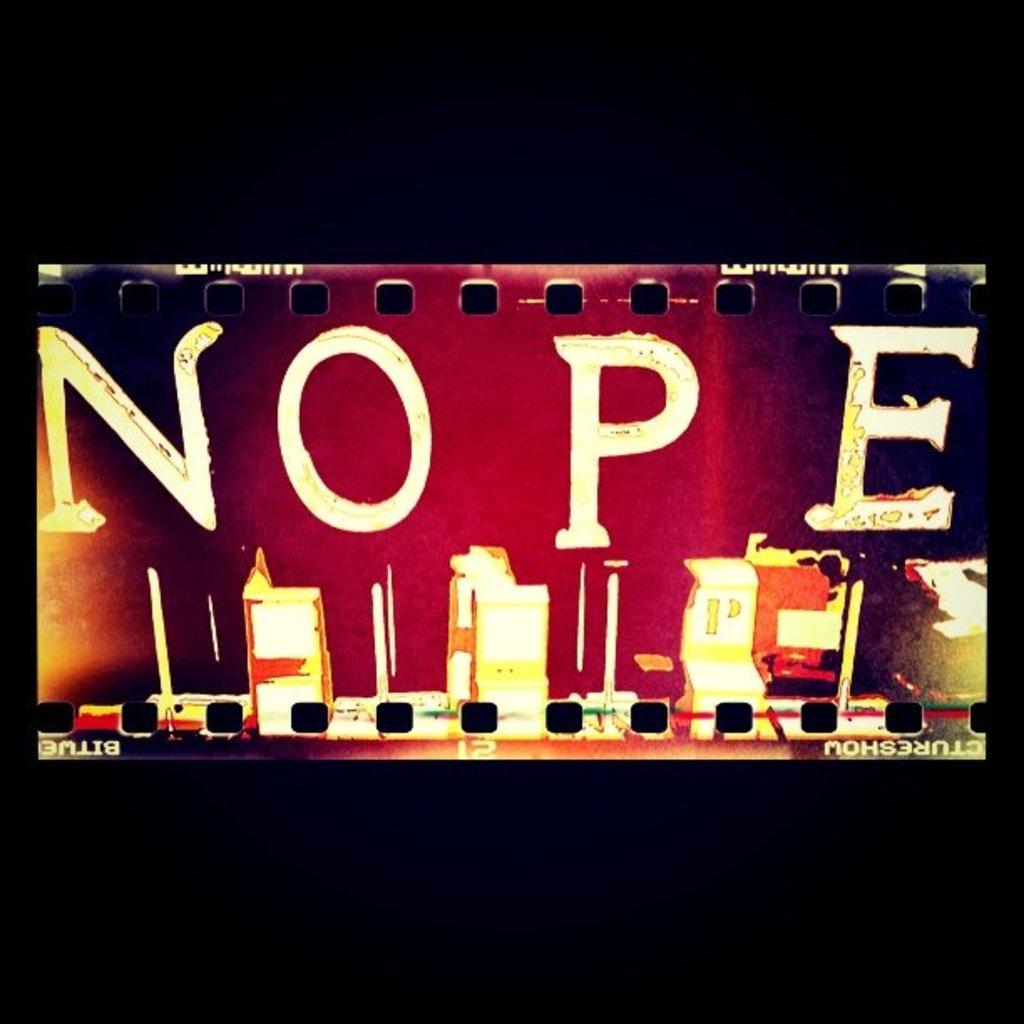Provide a one-sentence caption for the provided image. In bold letters the word NOPE is displayed on something that looks like old film. 